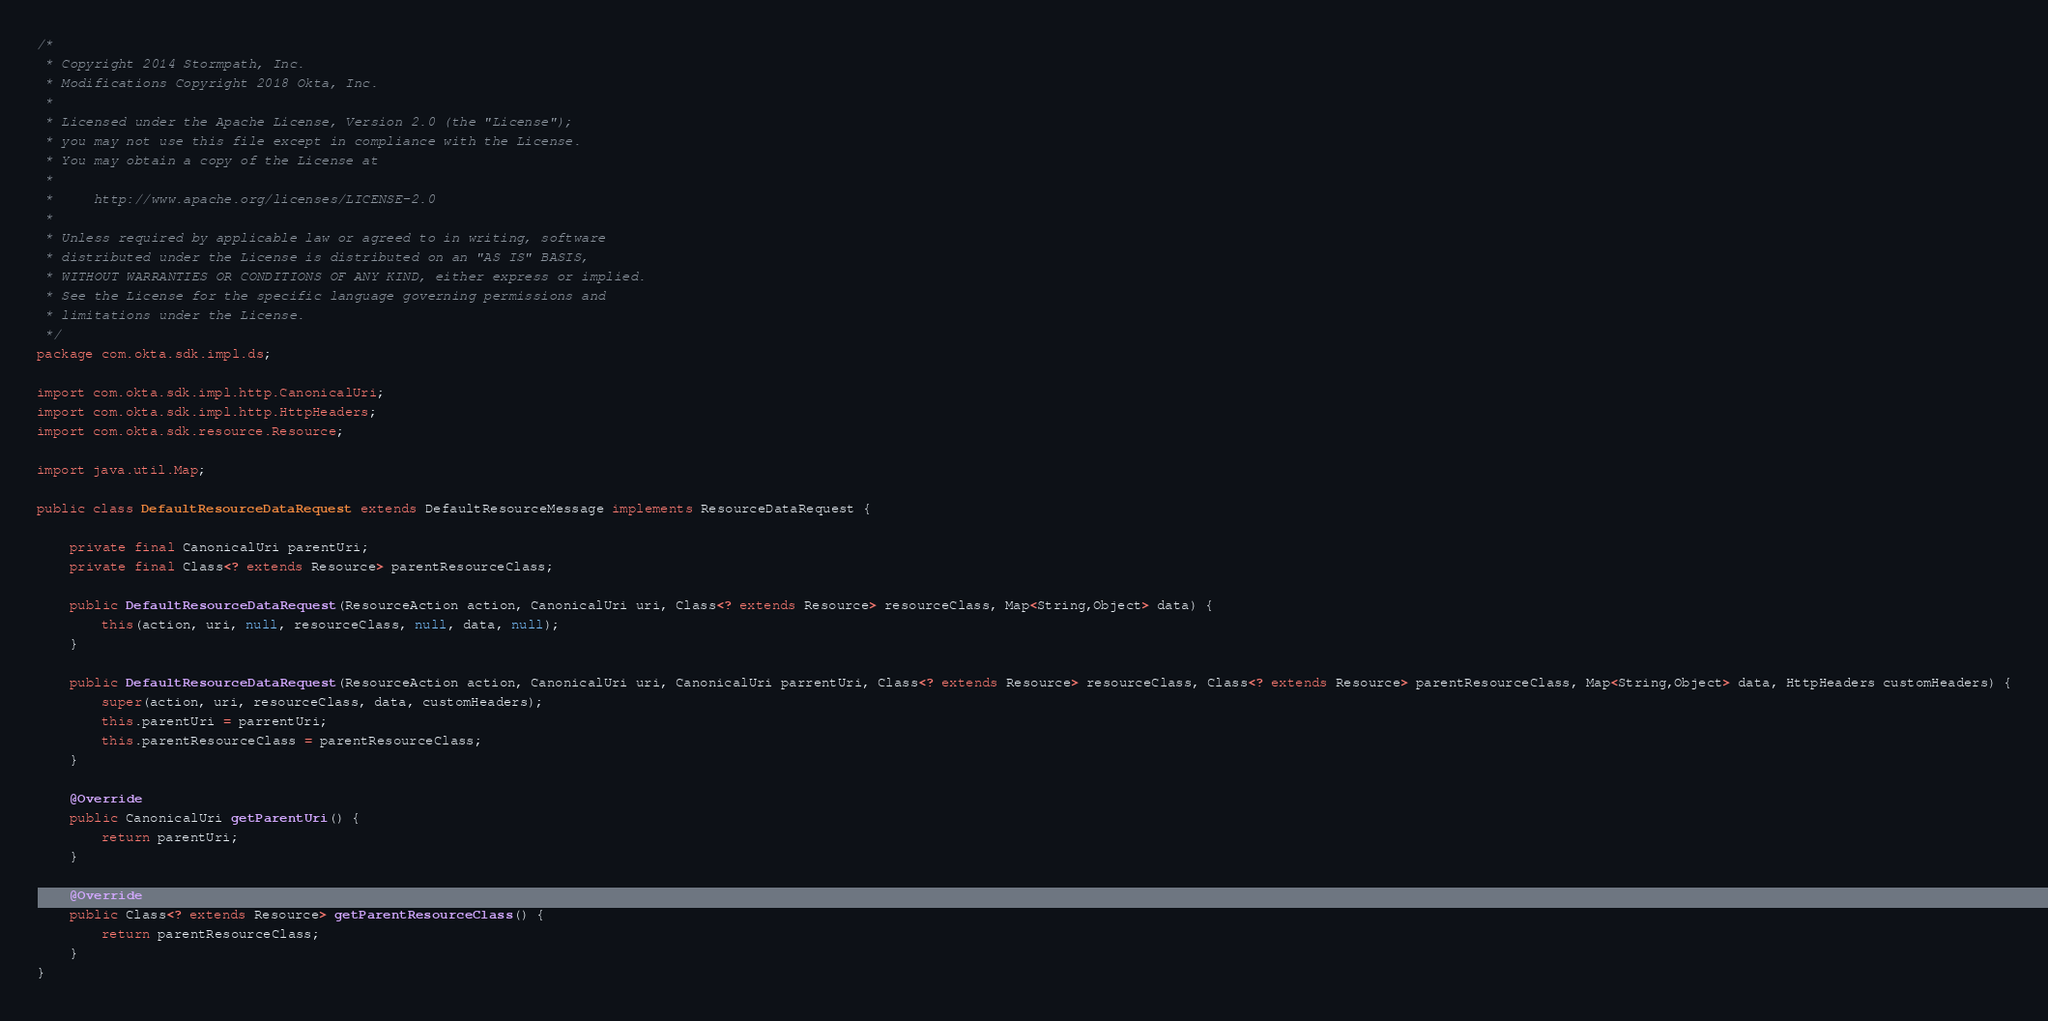Convert code to text. <code><loc_0><loc_0><loc_500><loc_500><_Java_>/*
 * Copyright 2014 Stormpath, Inc.
 * Modifications Copyright 2018 Okta, Inc.
 *
 * Licensed under the Apache License, Version 2.0 (the "License");
 * you may not use this file except in compliance with the License.
 * You may obtain a copy of the License at
 *
 *     http://www.apache.org/licenses/LICENSE-2.0
 *
 * Unless required by applicable law or agreed to in writing, software
 * distributed under the License is distributed on an "AS IS" BASIS,
 * WITHOUT WARRANTIES OR CONDITIONS OF ANY KIND, either express or implied.
 * See the License for the specific language governing permissions and
 * limitations under the License.
 */
package com.okta.sdk.impl.ds;

import com.okta.sdk.impl.http.CanonicalUri;
import com.okta.sdk.impl.http.HttpHeaders;
import com.okta.sdk.resource.Resource;

import java.util.Map;

public class DefaultResourceDataRequest extends DefaultResourceMessage implements ResourceDataRequest {

    private final CanonicalUri parentUri;
    private final Class<? extends Resource> parentResourceClass;

    public DefaultResourceDataRequest(ResourceAction action, CanonicalUri uri, Class<? extends Resource> resourceClass, Map<String,Object> data) {
        this(action, uri, null, resourceClass, null, data, null);
    }

    public DefaultResourceDataRequest(ResourceAction action, CanonicalUri uri, CanonicalUri parrentUri, Class<? extends Resource> resourceClass, Class<? extends Resource> parentResourceClass, Map<String,Object> data, HttpHeaders customHeaders) {
        super(action, uri, resourceClass, data, customHeaders);
        this.parentUri = parrentUri;
        this.parentResourceClass = parentResourceClass;
    }

    @Override
    public CanonicalUri getParentUri() {
        return parentUri;
    }

    @Override
    public Class<? extends Resource> getParentResourceClass() {
        return parentResourceClass;
    }
}</code> 